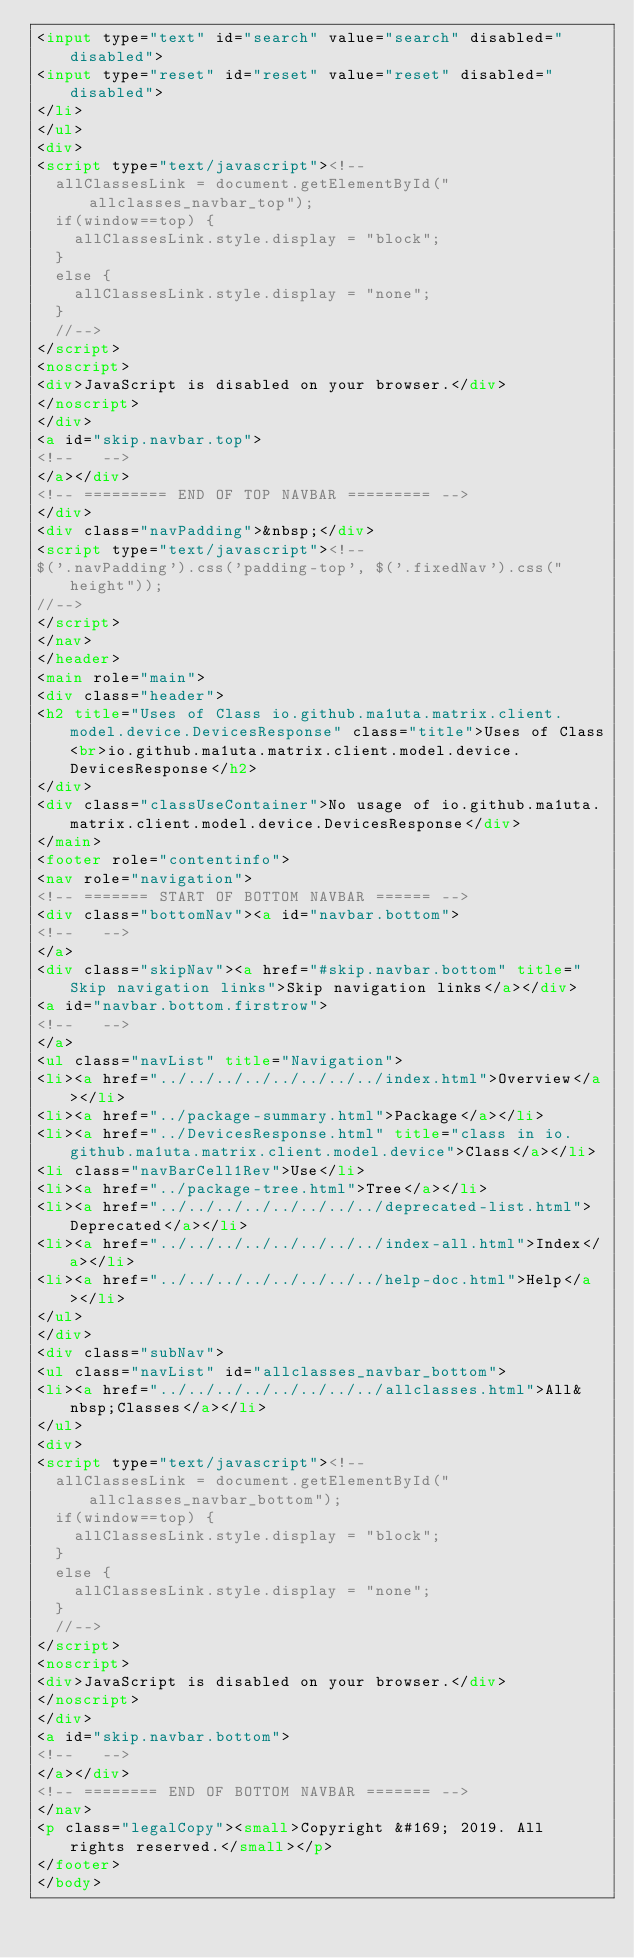Convert code to text. <code><loc_0><loc_0><loc_500><loc_500><_HTML_><input type="text" id="search" value="search" disabled="disabled">
<input type="reset" id="reset" value="reset" disabled="disabled">
</li>
</ul>
<div>
<script type="text/javascript"><!--
  allClassesLink = document.getElementById("allclasses_navbar_top");
  if(window==top) {
    allClassesLink.style.display = "block";
  }
  else {
    allClassesLink.style.display = "none";
  }
  //-->
</script>
<noscript>
<div>JavaScript is disabled on your browser.</div>
</noscript>
</div>
<a id="skip.navbar.top">
<!--   -->
</a></div>
<!-- ========= END OF TOP NAVBAR ========= -->
</div>
<div class="navPadding">&nbsp;</div>
<script type="text/javascript"><!--
$('.navPadding').css('padding-top', $('.fixedNav').css("height"));
//-->
</script>
</nav>
</header>
<main role="main">
<div class="header">
<h2 title="Uses of Class io.github.ma1uta.matrix.client.model.device.DevicesResponse" class="title">Uses of Class<br>io.github.ma1uta.matrix.client.model.device.DevicesResponse</h2>
</div>
<div class="classUseContainer">No usage of io.github.ma1uta.matrix.client.model.device.DevicesResponse</div>
</main>
<footer role="contentinfo">
<nav role="navigation">
<!-- ======= START OF BOTTOM NAVBAR ====== -->
<div class="bottomNav"><a id="navbar.bottom">
<!--   -->
</a>
<div class="skipNav"><a href="#skip.navbar.bottom" title="Skip navigation links">Skip navigation links</a></div>
<a id="navbar.bottom.firstrow">
<!--   -->
</a>
<ul class="navList" title="Navigation">
<li><a href="../../../../../../../../index.html">Overview</a></li>
<li><a href="../package-summary.html">Package</a></li>
<li><a href="../DevicesResponse.html" title="class in io.github.ma1uta.matrix.client.model.device">Class</a></li>
<li class="navBarCell1Rev">Use</li>
<li><a href="../package-tree.html">Tree</a></li>
<li><a href="../../../../../../../../deprecated-list.html">Deprecated</a></li>
<li><a href="../../../../../../../../index-all.html">Index</a></li>
<li><a href="../../../../../../../../help-doc.html">Help</a></li>
</ul>
</div>
<div class="subNav">
<ul class="navList" id="allclasses_navbar_bottom">
<li><a href="../../../../../../../../allclasses.html">All&nbsp;Classes</a></li>
</ul>
<div>
<script type="text/javascript"><!--
  allClassesLink = document.getElementById("allclasses_navbar_bottom");
  if(window==top) {
    allClassesLink.style.display = "block";
  }
  else {
    allClassesLink.style.display = "none";
  }
  //-->
</script>
<noscript>
<div>JavaScript is disabled on your browser.</div>
</noscript>
</div>
<a id="skip.navbar.bottom">
<!--   -->
</a></div>
<!-- ======== END OF BOTTOM NAVBAR ======= -->
</nav>
<p class="legalCopy"><small>Copyright &#169; 2019. All rights reserved.</small></p>
</footer>
</body></code> 